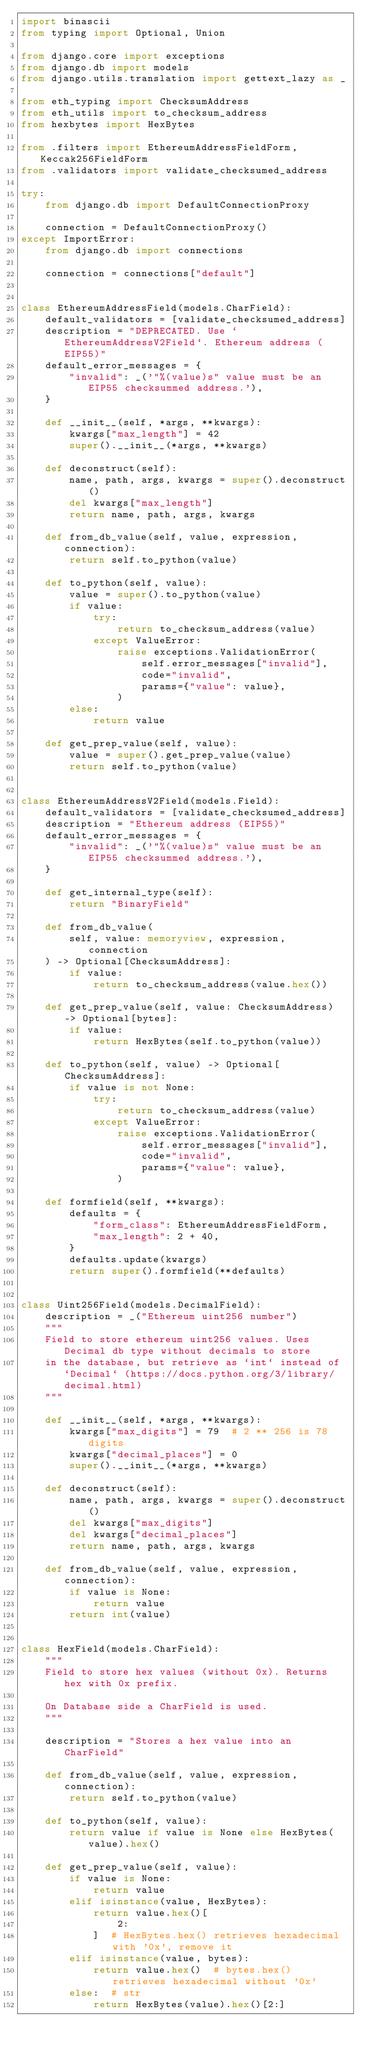<code> <loc_0><loc_0><loc_500><loc_500><_Python_>import binascii
from typing import Optional, Union

from django.core import exceptions
from django.db import models
from django.utils.translation import gettext_lazy as _

from eth_typing import ChecksumAddress
from eth_utils import to_checksum_address
from hexbytes import HexBytes

from .filters import EthereumAddressFieldForm, Keccak256FieldForm
from .validators import validate_checksumed_address

try:
    from django.db import DefaultConnectionProxy

    connection = DefaultConnectionProxy()
except ImportError:
    from django.db import connections

    connection = connections["default"]


class EthereumAddressField(models.CharField):
    default_validators = [validate_checksumed_address]
    description = "DEPRECATED. Use `EthereumAddressV2Field`. Ethereum address (EIP55)"
    default_error_messages = {
        "invalid": _('"%(value)s" value must be an EIP55 checksummed address.'),
    }

    def __init__(self, *args, **kwargs):
        kwargs["max_length"] = 42
        super().__init__(*args, **kwargs)

    def deconstruct(self):
        name, path, args, kwargs = super().deconstruct()
        del kwargs["max_length"]
        return name, path, args, kwargs

    def from_db_value(self, value, expression, connection):
        return self.to_python(value)

    def to_python(self, value):
        value = super().to_python(value)
        if value:
            try:
                return to_checksum_address(value)
            except ValueError:
                raise exceptions.ValidationError(
                    self.error_messages["invalid"],
                    code="invalid",
                    params={"value": value},
                )
        else:
            return value

    def get_prep_value(self, value):
        value = super().get_prep_value(value)
        return self.to_python(value)


class EthereumAddressV2Field(models.Field):
    default_validators = [validate_checksumed_address]
    description = "Ethereum address (EIP55)"
    default_error_messages = {
        "invalid": _('"%(value)s" value must be an EIP55 checksummed address.'),
    }

    def get_internal_type(self):
        return "BinaryField"

    def from_db_value(
        self, value: memoryview, expression, connection
    ) -> Optional[ChecksumAddress]:
        if value:
            return to_checksum_address(value.hex())

    def get_prep_value(self, value: ChecksumAddress) -> Optional[bytes]:
        if value:
            return HexBytes(self.to_python(value))

    def to_python(self, value) -> Optional[ChecksumAddress]:
        if value is not None:
            try:
                return to_checksum_address(value)
            except ValueError:
                raise exceptions.ValidationError(
                    self.error_messages["invalid"],
                    code="invalid",
                    params={"value": value},
                )

    def formfield(self, **kwargs):
        defaults = {
            "form_class": EthereumAddressFieldForm,
            "max_length": 2 + 40,
        }
        defaults.update(kwargs)
        return super().formfield(**defaults)


class Uint256Field(models.DecimalField):
    description = _("Ethereum uint256 number")
    """
    Field to store ethereum uint256 values. Uses Decimal db type without decimals to store
    in the database, but retrieve as `int` instead of `Decimal` (https://docs.python.org/3/library/decimal.html)
    """

    def __init__(self, *args, **kwargs):
        kwargs["max_digits"] = 79  # 2 ** 256 is 78 digits
        kwargs["decimal_places"] = 0
        super().__init__(*args, **kwargs)

    def deconstruct(self):
        name, path, args, kwargs = super().deconstruct()
        del kwargs["max_digits"]
        del kwargs["decimal_places"]
        return name, path, args, kwargs

    def from_db_value(self, value, expression, connection):
        if value is None:
            return value
        return int(value)


class HexField(models.CharField):
    """
    Field to store hex values (without 0x). Returns hex with 0x prefix.

    On Database side a CharField is used.
    """

    description = "Stores a hex value into an CharField"

    def from_db_value(self, value, expression, connection):
        return self.to_python(value)

    def to_python(self, value):
        return value if value is None else HexBytes(value).hex()

    def get_prep_value(self, value):
        if value is None:
            return value
        elif isinstance(value, HexBytes):
            return value.hex()[
                2:
            ]  # HexBytes.hex() retrieves hexadecimal with '0x', remove it
        elif isinstance(value, bytes):
            return value.hex()  # bytes.hex() retrieves hexadecimal without '0x'
        else:  # str
            return HexBytes(value).hex()[2:]
</code> 